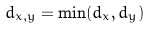<formula> <loc_0><loc_0><loc_500><loc_500>d _ { x , y } = \min ( d _ { x } , d _ { y } )</formula> 